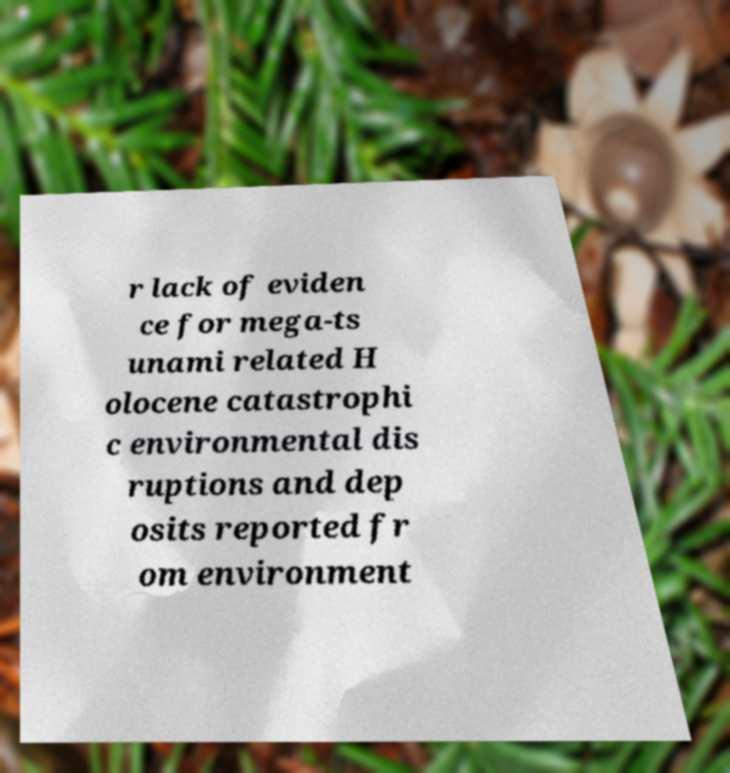Can you read and provide the text displayed in the image?This photo seems to have some interesting text. Can you extract and type it out for me? r lack of eviden ce for mega-ts unami related H olocene catastrophi c environmental dis ruptions and dep osits reported fr om environment 